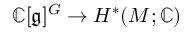<formula> <loc_0><loc_0><loc_500><loc_500>\mathbb { C } [ { \mathfrak { g } } ] ^ { G } \rightarrow H ^ { * } ( M ; \mathbb { C } )</formula> 